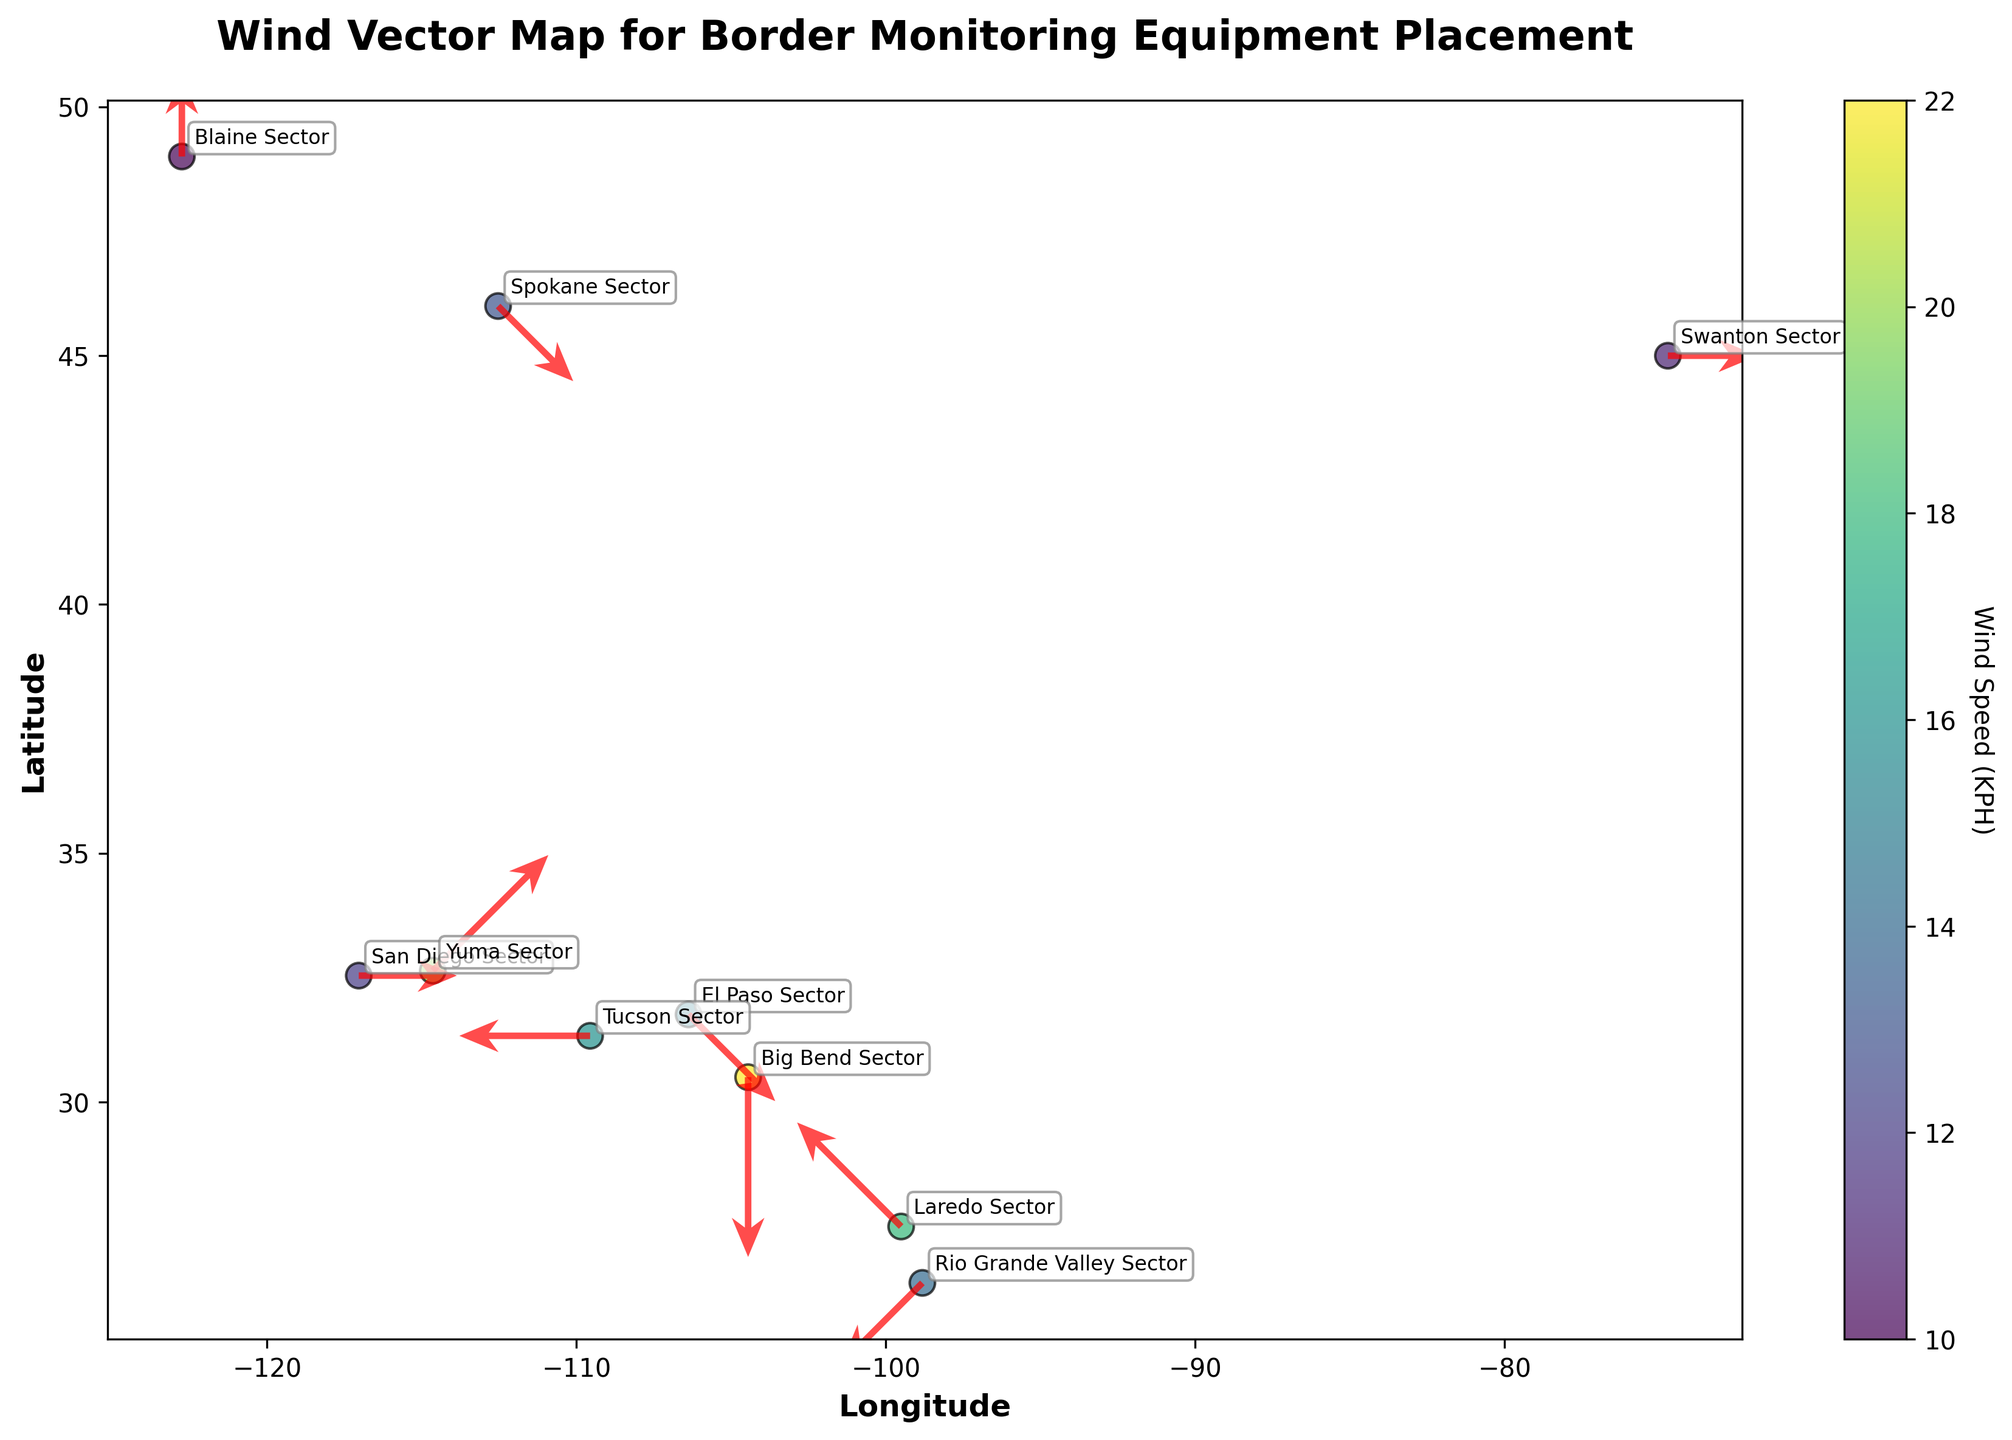What is the title of the plot? The title is displayed prominently at the top of the plot and usually provides a brief description of what the plot represents.
Answer: Wind Vector Map for Border Monitoring Equipment Placement Which border section experiences the highest wind speed? The plot uses color coding to indicate wind speeds, with darker colors representing higher speeds. The annotations next to the data points identify the specific border sections. By checking the colors and corresponding annotations, you can identify that Big Bend Sector has the highest wind speed.
Answer: Big Bend Sector Which direction is the wind blowing in the San Diego Sector? The directions of the wind vectors are illustrated using arrows in the plot. The arrow for the San Diego Sector points to the left, indicating that the wind direction is W.
Answer: W How many border sections are represented in the plot? Each annotation label in the plot represents a unique border section. By counting these labels, you can find the total number of border sections.
Answer: 10 Which border section has the lowest wind speed, and what is the speed? The color bar indicates that the lighter colors represent lower wind speeds. The Blaine Sector has the lightest color and annotations confirming a wind speed of 10 KPH.
Answer: Blaine Sector; 10 KPH In which direction is the wind blowing in the Tucson Sector, and what is the wind speed? The annotation identifies the Tucson Sector, and the adjacent arrow indicates the direction. The plot also uses color coding to indicate wind speed. The arrow points right (East), and the Tucson Sector is color-coded for a wind speed of 16 KPH.
Answer: E; 16 KPH Compare the wind speeds of the Yuma Sector and El Paso Sector. Which one is higher, and by how much? The color bar and annotations show the wind speeds for the Yuma Sector (20 KPH) and El Paso Sector (15 KPH). By subtracting these values, you find that the Yuma Sector has a 5 KPH higher wind speed than the El Paso Sector.
Answer: Yuma Sector; 5 KPH What is the predominant terrain type in sectors experiencing wind speeds over 15 KPH? From the annotations and terrain type descriptions next to the data points, you can see that the El Paso, Laredo, Yuma, Tucson, and Big Bend sectors all experience wind speeds over 15 KPH. Most of these sectors are Deserts.
Answer: Desert How does the wind direction in the Big Bend Sector compare to the wind direction in the Rio Grande Valley Sector? By observing the arrows and annotations, the wind direction in the Big Bend Sector is N, while it is NE in the Rio Grande Valley Sector. Comparing these directions shows that the Big Bend Sector wind is northward, while the Rio Grande Valley Sector wind is northeastward.
Answer: N; NE 